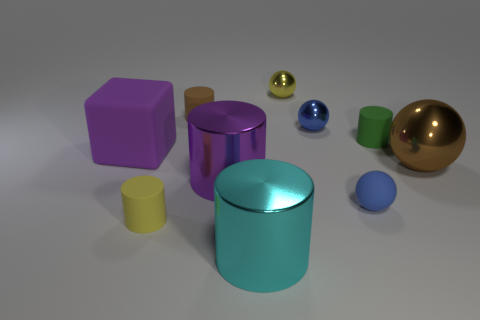There is a metal thing that is the same color as the cube; what is its shape?
Ensure brevity in your answer.  Cylinder. What color is the tiny matte ball?
Your answer should be compact. Blue. There is a brown object that is to the right of the tiny yellow thing behind the tiny cylinder that is on the right side of the large cyan cylinder; what shape is it?
Your answer should be very brief. Sphere. There is a cylinder that is behind the cube and on the right side of the tiny brown matte object; what is it made of?
Your answer should be compact. Rubber. What shape is the blue thing that is in front of the block left of the large brown metal object?
Provide a short and direct response. Sphere. Is there anything else that is the same color as the block?
Your response must be concise. Yes. There is a yellow shiny thing; does it have the same size as the rubber cylinder that is in front of the purple matte thing?
Offer a terse response. Yes. What number of big things are blue rubber cylinders or cubes?
Ensure brevity in your answer.  1. Is the number of blue metal cylinders greater than the number of tiny green objects?
Provide a succinct answer. No. There is a cylinder right of the ball behind the blue metal ball; how many tiny objects are behind it?
Provide a short and direct response. 3. 